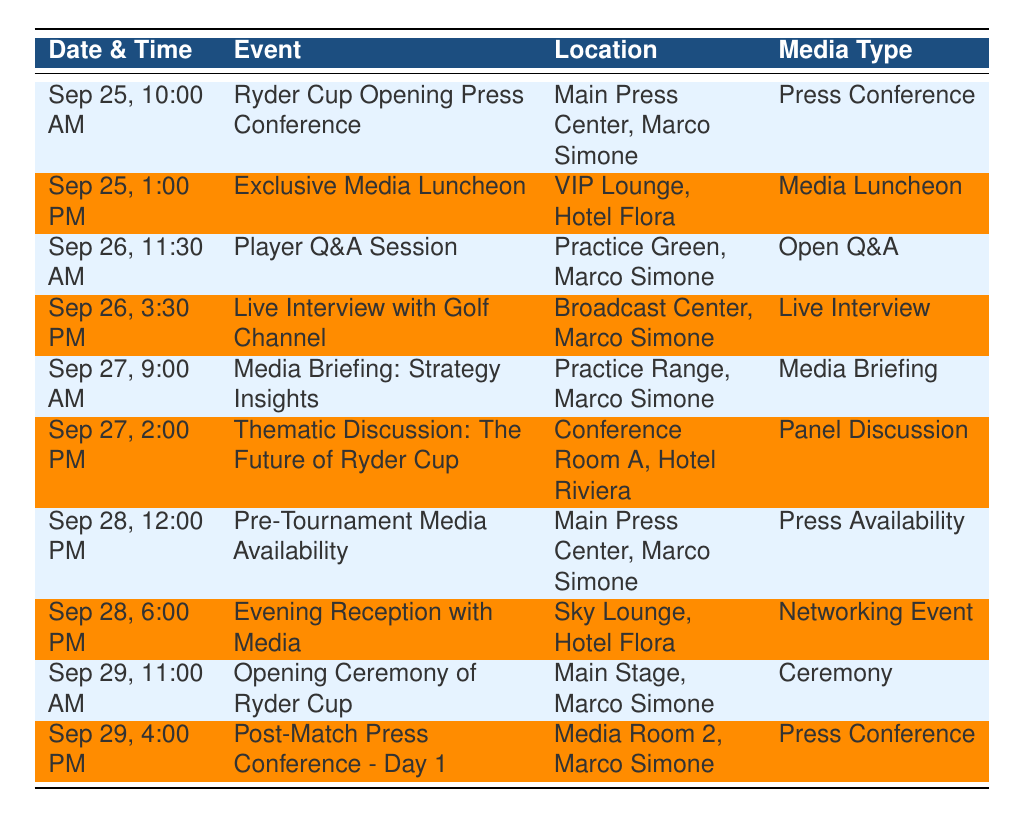What time is the Ryder Cup Opening Press Conference scheduled? The Ryder Cup Opening Press Conference is listed under the event that occurs on September 25 at 10:00 AM.
Answer: 10:00 AM Who are the participants in the Exclusive Media Luncheon? The Exclusive Media Luncheon scheduled for September 25 at 1:00 PM has two participants: Tom Adams and Sophie Williams.
Answer: Tom Adams, Sophie Williams Is there a Live Interview with Golf Channel on September 26? Yes, there is a Live Interview with Golf Channel scheduled for September 26 at 3:30 PM, featuring the professional golfer.
Answer: Yes How many media appearances are scheduled for September 28? On September 28, there are two scheduled media appearances: Pre-Tournament Media Availability at 12:00 PM and Evening Reception with Media at 6:00 PM.
Answer: 2 Which event has the earliest time in the schedule? The earliest scheduled event is the Ryder Cup Opening Press Conference on September 25 at 10:00 AM. To find this, we compare the times of all events and identify the earliest one.
Answer: Ryder Cup Opening Press Conference On which date does the first media appearance occur, and what is it? The first media appearance is on September 25, and it is the Ryder Cup Opening Press Conference at 10:00 AM. We refer to the dates in the table to identify the first entry.
Answer: September 25, Ryder Cup Opening Press Conference What is the location of the opening ceremony of the Ryder Cup? The opening ceremony of the Ryder Cup is scheduled for September 29 at 11:00 AM at Main Stage, Marco Simone. This can be found by looking at the entry for the opening ceremony in the date column.
Answer: Main Stage, Marco Simone How many total events are categorized under Press Conference? There are three events categorized under Press Conference: Ryder Cup Opening Press Conference on September 25, Pre-Tournament Media Availability on September 28, and Post-Match Press Conference - Day 1 on September 29. By counting these entries under the Media Type column, we find the total.
Answer: 3 Is there a Media Briefing scheduled on September 27? Yes, there is a Media Briefing: Strategy Insights scheduled on September 27 at 9:00 AM, involving Coach Richard Lee. This is confirmed by locating that specific entry in the table.
Answer: Yes 